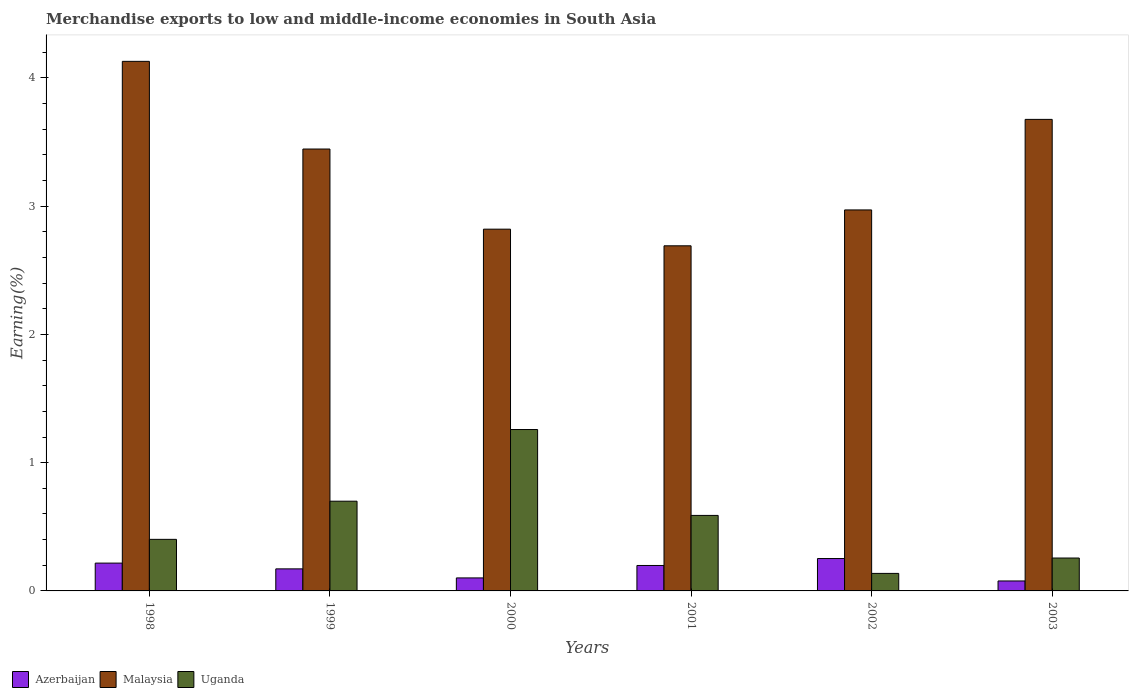How many different coloured bars are there?
Provide a succinct answer. 3. How many bars are there on the 4th tick from the right?
Ensure brevity in your answer.  3. In how many cases, is the number of bars for a given year not equal to the number of legend labels?
Provide a short and direct response. 0. What is the percentage of amount earned from merchandise exports in Uganda in 1998?
Ensure brevity in your answer.  0.4. Across all years, what is the maximum percentage of amount earned from merchandise exports in Azerbaijan?
Your response must be concise. 0.25. Across all years, what is the minimum percentage of amount earned from merchandise exports in Malaysia?
Keep it short and to the point. 2.69. What is the total percentage of amount earned from merchandise exports in Uganda in the graph?
Keep it short and to the point. 3.34. What is the difference between the percentage of amount earned from merchandise exports in Uganda in 1998 and that in 1999?
Provide a succinct answer. -0.3. What is the difference between the percentage of amount earned from merchandise exports in Uganda in 2003 and the percentage of amount earned from merchandise exports in Malaysia in 1999?
Your answer should be compact. -3.19. What is the average percentage of amount earned from merchandise exports in Azerbaijan per year?
Ensure brevity in your answer.  0.17. In the year 1999, what is the difference between the percentage of amount earned from merchandise exports in Azerbaijan and percentage of amount earned from merchandise exports in Uganda?
Offer a terse response. -0.53. In how many years, is the percentage of amount earned from merchandise exports in Malaysia greater than 0.6000000000000001 %?
Ensure brevity in your answer.  6. What is the ratio of the percentage of amount earned from merchandise exports in Azerbaijan in 1998 to that in 2002?
Provide a succinct answer. 0.86. What is the difference between the highest and the second highest percentage of amount earned from merchandise exports in Azerbaijan?
Offer a terse response. 0.04. What is the difference between the highest and the lowest percentage of amount earned from merchandise exports in Malaysia?
Offer a very short reply. 1.44. In how many years, is the percentage of amount earned from merchandise exports in Azerbaijan greater than the average percentage of amount earned from merchandise exports in Azerbaijan taken over all years?
Your answer should be compact. 4. Is the sum of the percentage of amount earned from merchandise exports in Malaysia in 2000 and 2001 greater than the maximum percentage of amount earned from merchandise exports in Azerbaijan across all years?
Offer a terse response. Yes. What does the 2nd bar from the left in 2001 represents?
Keep it short and to the point. Malaysia. What does the 3rd bar from the right in 2000 represents?
Keep it short and to the point. Azerbaijan. Is it the case that in every year, the sum of the percentage of amount earned from merchandise exports in Azerbaijan and percentage of amount earned from merchandise exports in Uganda is greater than the percentage of amount earned from merchandise exports in Malaysia?
Your answer should be very brief. No. How many bars are there?
Make the answer very short. 18. How many years are there in the graph?
Give a very brief answer. 6. Are the values on the major ticks of Y-axis written in scientific E-notation?
Provide a succinct answer. No. Does the graph contain any zero values?
Make the answer very short. No. How many legend labels are there?
Offer a terse response. 3. What is the title of the graph?
Provide a short and direct response. Merchandise exports to low and middle-income economies in South Asia. Does "Sweden" appear as one of the legend labels in the graph?
Provide a succinct answer. No. What is the label or title of the Y-axis?
Offer a terse response. Earning(%). What is the Earning(%) in Azerbaijan in 1998?
Keep it short and to the point. 0.22. What is the Earning(%) of Malaysia in 1998?
Your response must be concise. 4.13. What is the Earning(%) in Uganda in 1998?
Your answer should be very brief. 0.4. What is the Earning(%) in Azerbaijan in 1999?
Your answer should be compact. 0.17. What is the Earning(%) of Malaysia in 1999?
Provide a succinct answer. 3.45. What is the Earning(%) of Uganda in 1999?
Offer a terse response. 0.7. What is the Earning(%) in Azerbaijan in 2000?
Your response must be concise. 0.1. What is the Earning(%) of Malaysia in 2000?
Your response must be concise. 2.82. What is the Earning(%) of Uganda in 2000?
Make the answer very short. 1.26. What is the Earning(%) in Azerbaijan in 2001?
Offer a very short reply. 0.2. What is the Earning(%) of Malaysia in 2001?
Provide a succinct answer. 2.69. What is the Earning(%) in Uganda in 2001?
Offer a very short reply. 0.59. What is the Earning(%) in Azerbaijan in 2002?
Keep it short and to the point. 0.25. What is the Earning(%) in Malaysia in 2002?
Ensure brevity in your answer.  2.97. What is the Earning(%) in Uganda in 2002?
Give a very brief answer. 0.14. What is the Earning(%) in Azerbaijan in 2003?
Offer a terse response. 0.08. What is the Earning(%) of Malaysia in 2003?
Keep it short and to the point. 3.68. What is the Earning(%) of Uganda in 2003?
Provide a succinct answer. 0.26. Across all years, what is the maximum Earning(%) in Azerbaijan?
Ensure brevity in your answer.  0.25. Across all years, what is the maximum Earning(%) in Malaysia?
Provide a short and direct response. 4.13. Across all years, what is the maximum Earning(%) of Uganda?
Make the answer very short. 1.26. Across all years, what is the minimum Earning(%) in Azerbaijan?
Provide a short and direct response. 0.08. Across all years, what is the minimum Earning(%) of Malaysia?
Give a very brief answer. 2.69. Across all years, what is the minimum Earning(%) of Uganda?
Your answer should be compact. 0.14. What is the total Earning(%) of Azerbaijan in the graph?
Ensure brevity in your answer.  1.02. What is the total Earning(%) of Malaysia in the graph?
Keep it short and to the point. 19.73. What is the total Earning(%) in Uganda in the graph?
Your response must be concise. 3.34. What is the difference between the Earning(%) of Azerbaijan in 1998 and that in 1999?
Ensure brevity in your answer.  0.04. What is the difference between the Earning(%) of Malaysia in 1998 and that in 1999?
Your response must be concise. 0.68. What is the difference between the Earning(%) in Uganda in 1998 and that in 1999?
Give a very brief answer. -0.3. What is the difference between the Earning(%) of Azerbaijan in 1998 and that in 2000?
Offer a very short reply. 0.12. What is the difference between the Earning(%) of Malaysia in 1998 and that in 2000?
Your answer should be compact. 1.31. What is the difference between the Earning(%) in Uganda in 1998 and that in 2000?
Keep it short and to the point. -0.86. What is the difference between the Earning(%) in Azerbaijan in 1998 and that in 2001?
Provide a short and direct response. 0.02. What is the difference between the Earning(%) in Malaysia in 1998 and that in 2001?
Keep it short and to the point. 1.44. What is the difference between the Earning(%) of Uganda in 1998 and that in 2001?
Offer a terse response. -0.19. What is the difference between the Earning(%) of Azerbaijan in 1998 and that in 2002?
Ensure brevity in your answer.  -0.04. What is the difference between the Earning(%) of Malaysia in 1998 and that in 2002?
Provide a succinct answer. 1.16. What is the difference between the Earning(%) in Uganda in 1998 and that in 2002?
Provide a short and direct response. 0.27. What is the difference between the Earning(%) in Azerbaijan in 1998 and that in 2003?
Ensure brevity in your answer.  0.14. What is the difference between the Earning(%) of Malaysia in 1998 and that in 2003?
Provide a short and direct response. 0.45. What is the difference between the Earning(%) in Uganda in 1998 and that in 2003?
Offer a terse response. 0.15. What is the difference between the Earning(%) in Azerbaijan in 1999 and that in 2000?
Your answer should be very brief. 0.07. What is the difference between the Earning(%) of Malaysia in 1999 and that in 2000?
Your answer should be compact. 0.62. What is the difference between the Earning(%) in Uganda in 1999 and that in 2000?
Provide a short and direct response. -0.56. What is the difference between the Earning(%) of Azerbaijan in 1999 and that in 2001?
Your answer should be compact. -0.03. What is the difference between the Earning(%) of Malaysia in 1999 and that in 2001?
Keep it short and to the point. 0.75. What is the difference between the Earning(%) in Uganda in 1999 and that in 2001?
Your answer should be compact. 0.11. What is the difference between the Earning(%) in Azerbaijan in 1999 and that in 2002?
Offer a terse response. -0.08. What is the difference between the Earning(%) in Malaysia in 1999 and that in 2002?
Provide a succinct answer. 0.47. What is the difference between the Earning(%) of Uganda in 1999 and that in 2002?
Make the answer very short. 0.56. What is the difference between the Earning(%) of Azerbaijan in 1999 and that in 2003?
Your answer should be very brief. 0.09. What is the difference between the Earning(%) of Malaysia in 1999 and that in 2003?
Keep it short and to the point. -0.23. What is the difference between the Earning(%) in Uganda in 1999 and that in 2003?
Keep it short and to the point. 0.44. What is the difference between the Earning(%) in Azerbaijan in 2000 and that in 2001?
Your response must be concise. -0.1. What is the difference between the Earning(%) of Malaysia in 2000 and that in 2001?
Your answer should be very brief. 0.13. What is the difference between the Earning(%) of Uganda in 2000 and that in 2001?
Provide a short and direct response. 0.67. What is the difference between the Earning(%) of Azerbaijan in 2000 and that in 2002?
Ensure brevity in your answer.  -0.15. What is the difference between the Earning(%) in Malaysia in 2000 and that in 2002?
Offer a very short reply. -0.15. What is the difference between the Earning(%) in Uganda in 2000 and that in 2002?
Give a very brief answer. 1.12. What is the difference between the Earning(%) in Azerbaijan in 2000 and that in 2003?
Offer a very short reply. 0.02. What is the difference between the Earning(%) in Malaysia in 2000 and that in 2003?
Provide a short and direct response. -0.86. What is the difference between the Earning(%) of Uganda in 2000 and that in 2003?
Offer a terse response. 1. What is the difference between the Earning(%) in Azerbaijan in 2001 and that in 2002?
Your answer should be compact. -0.05. What is the difference between the Earning(%) in Malaysia in 2001 and that in 2002?
Ensure brevity in your answer.  -0.28. What is the difference between the Earning(%) in Uganda in 2001 and that in 2002?
Your response must be concise. 0.45. What is the difference between the Earning(%) in Azerbaijan in 2001 and that in 2003?
Keep it short and to the point. 0.12. What is the difference between the Earning(%) of Malaysia in 2001 and that in 2003?
Your response must be concise. -0.99. What is the difference between the Earning(%) of Uganda in 2001 and that in 2003?
Provide a short and direct response. 0.33. What is the difference between the Earning(%) of Azerbaijan in 2002 and that in 2003?
Keep it short and to the point. 0.17. What is the difference between the Earning(%) in Malaysia in 2002 and that in 2003?
Make the answer very short. -0.71. What is the difference between the Earning(%) in Uganda in 2002 and that in 2003?
Keep it short and to the point. -0.12. What is the difference between the Earning(%) of Azerbaijan in 1998 and the Earning(%) of Malaysia in 1999?
Offer a terse response. -3.23. What is the difference between the Earning(%) in Azerbaijan in 1998 and the Earning(%) in Uganda in 1999?
Your response must be concise. -0.48. What is the difference between the Earning(%) of Malaysia in 1998 and the Earning(%) of Uganda in 1999?
Provide a succinct answer. 3.43. What is the difference between the Earning(%) of Azerbaijan in 1998 and the Earning(%) of Malaysia in 2000?
Give a very brief answer. -2.6. What is the difference between the Earning(%) in Azerbaijan in 1998 and the Earning(%) in Uganda in 2000?
Your answer should be compact. -1.04. What is the difference between the Earning(%) of Malaysia in 1998 and the Earning(%) of Uganda in 2000?
Give a very brief answer. 2.87. What is the difference between the Earning(%) in Azerbaijan in 1998 and the Earning(%) in Malaysia in 2001?
Offer a terse response. -2.47. What is the difference between the Earning(%) of Azerbaijan in 1998 and the Earning(%) of Uganda in 2001?
Offer a terse response. -0.37. What is the difference between the Earning(%) of Malaysia in 1998 and the Earning(%) of Uganda in 2001?
Provide a short and direct response. 3.54. What is the difference between the Earning(%) in Azerbaijan in 1998 and the Earning(%) in Malaysia in 2002?
Offer a very short reply. -2.75. What is the difference between the Earning(%) in Azerbaijan in 1998 and the Earning(%) in Uganda in 2002?
Ensure brevity in your answer.  0.08. What is the difference between the Earning(%) in Malaysia in 1998 and the Earning(%) in Uganda in 2002?
Keep it short and to the point. 3.99. What is the difference between the Earning(%) in Azerbaijan in 1998 and the Earning(%) in Malaysia in 2003?
Keep it short and to the point. -3.46. What is the difference between the Earning(%) in Azerbaijan in 1998 and the Earning(%) in Uganda in 2003?
Offer a terse response. -0.04. What is the difference between the Earning(%) in Malaysia in 1998 and the Earning(%) in Uganda in 2003?
Provide a short and direct response. 3.87. What is the difference between the Earning(%) of Azerbaijan in 1999 and the Earning(%) of Malaysia in 2000?
Provide a short and direct response. -2.65. What is the difference between the Earning(%) of Azerbaijan in 1999 and the Earning(%) of Uganda in 2000?
Provide a succinct answer. -1.09. What is the difference between the Earning(%) in Malaysia in 1999 and the Earning(%) in Uganda in 2000?
Your answer should be compact. 2.19. What is the difference between the Earning(%) of Azerbaijan in 1999 and the Earning(%) of Malaysia in 2001?
Offer a terse response. -2.52. What is the difference between the Earning(%) in Azerbaijan in 1999 and the Earning(%) in Uganda in 2001?
Ensure brevity in your answer.  -0.42. What is the difference between the Earning(%) of Malaysia in 1999 and the Earning(%) of Uganda in 2001?
Offer a very short reply. 2.86. What is the difference between the Earning(%) in Azerbaijan in 1999 and the Earning(%) in Malaysia in 2002?
Provide a short and direct response. -2.8. What is the difference between the Earning(%) of Azerbaijan in 1999 and the Earning(%) of Uganda in 2002?
Make the answer very short. 0.04. What is the difference between the Earning(%) in Malaysia in 1999 and the Earning(%) in Uganda in 2002?
Ensure brevity in your answer.  3.31. What is the difference between the Earning(%) of Azerbaijan in 1999 and the Earning(%) of Malaysia in 2003?
Keep it short and to the point. -3.5. What is the difference between the Earning(%) in Azerbaijan in 1999 and the Earning(%) in Uganda in 2003?
Your response must be concise. -0.08. What is the difference between the Earning(%) in Malaysia in 1999 and the Earning(%) in Uganda in 2003?
Your answer should be very brief. 3.19. What is the difference between the Earning(%) in Azerbaijan in 2000 and the Earning(%) in Malaysia in 2001?
Your answer should be very brief. -2.59. What is the difference between the Earning(%) of Azerbaijan in 2000 and the Earning(%) of Uganda in 2001?
Your answer should be compact. -0.49. What is the difference between the Earning(%) of Malaysia in 2000 and the Earning(%) of Uganda in 2001?
Offer a terse response. 2.23. What is the difference between the Earning(%) in Azerbaijan in 2000 and the Earning(%) in Malaysia in 2002?
Your response must be concise. -2.87. What is the difference between the Earning(%) of Azerbaijan in 2000 and the Earning(%) of Uganda in 2002?
Your answer should be compact. -0.04. What is the difference between the Earning(%) in Malaysia in 2000 and the Earning(%) in Uganda in 2002?
Offer a very short reply. 2.68. What is the difference between the Earning(%) of Azerbaijan in 2000 and the Earning(%) of Malaysia in 2003?
Offer a very short reply. -3.58. What is the difference between the Earning(%) in Azerbaijan in 2000 and the Earning(%) in Uganda in 2003?
Your response must be concise. -0.16. What is the difference between the Earning(%) of Malaysia in 2000 and the Earning(%) of Uganda in 2003?
Provide a short and direct response. 2.56. What is the difference between the Earning(%) in Azerbaijan in 2001 and the Earning(%) in Malaysia in 2002?
Provide a succinct answer. -2.77. What is the difference between the Earning(%) of Azerbaijan in 2001 and the Earning(%) of Uganda in 2002?
Make the answer very short. 0.06. What is the difference between the Earning(%) in Malaysia in 2001 and the Earning(%) in Uganda in 2002?
Your answer should be compact. 2.55. What is the difference between the Earning(%) in Azerbaijan in 2001 and the Earning(%) in Malaysia in 2003?
Offer a terse response. -3.48. What is the difference between the Earning(%) in Azerbaijan in 2001 and the Earning(%) in Uganda in 2003?
Provide a succinct answer. -0.06. What is the difference between the Earning(%) in Malaysia in 2001 and the Earning(%) in Uganda in 2003?
Keep it short and to the point. 2.43. What is the difference between the Earning(%) in Azerbaijan in 2002 and the Earning(%) in Malaysia in 2003?
Provide a short and direct response. -3.42. What is the difference between the Earning(%) in Azerbaijan in 2002 and the Earning(%) in Uganda in 2003?
Your response must be concise. -0. What is the difference between the Earning(%) of Malaysia in 2002 and the Earning(%) of Uganda in 2003?
Your response must be concise. 2.71. What is the average Earning(%) of Azerbaijan per year?
Your answer should be very brief. 0.17. What is the average Earning(%) in Malaysia per year?
Give a very brief answer. 3.29. What is the average Earning(%) in Uganda per year?
Your response must be concise. 0.56. In the year 1998, what is the difference between the Earning(%) of Azerbaijan and Earning(%) of Malaysia?
Give a very brief answer. -3.91. In the year 1998, what is the difference between the Earning(%) of Azerbaijan and Earning(%) of Uganda?
Provide a short and direct response. -0.19. In the year 1998, what is the difference between the Earning(%) in Malaysia and Earning(%) in Uganda?
Ensure brevity in your answer.  3.73. In the year 1999, what is the difference between the Earning(%) of Azerbaijan and Earning(%) of Malaysia?
Your answer should be compact. -3.27. In the year 1999, what is the difference between the Earning(%) in Azerbaijan and Earning(%) in Uganda?
Offer a terse response. -0.53. In the year 1999, what is the difference between the Earning(%) in Malaysia and Earning(%) in Uganda?
Provide a succinct answer. 2.75. In the year 2000, what is the difference between the Earning(%) of Azerbaijan and Earning(%) of Malaysia?
Your response must be concise. -2.72. In the year 2000, what is the difference between the Earning(%) in Azerbaijan and Earning(%) in Uganda?
Offer a terse response. -1.16. In the year 2000, what is the difference between the Earning(%) of Malaysia and Earning(%) of Uganda?
Your answer should be compact. 1.56. In the year 2001, what is the difference between the Earning(%) in Azerbaijan and Earning(%) in Malaysia?
Keep it short and to the point. -2.49. In the year 2001, what is the difference between the Earning(%) of Azerbaijan and Earning(%) of Uganda?
Your answer should be compact. -0.39. In the year 2001, what is the difference between the Earning(%) in Malaysia and Earning(%) in Uganda?
Your answer should be compact. 2.1. In the year 2002, what is the difference between the Earning(%) in Azerbaijan and Earning(%) in Malaysia?
Provide a short and direct response. -2.72. In the year 2002, what is the difference between the Earning(%) of Azerbaijan and Earning(%) of Uganda?
Your response must be concise. 0.12. In the year 2002, what is the difference between the Earning(%) in Malaysia and Earning(%) in Uganda?
Offer a very short reply. 2.83. In the year 2003, what is the difference between the Earning(%) in Azerbaijan and Earning(%) in Malaysia?
Give a very brief answer. -3.6. In the year 2003, what is the difference between the Earning(%) of Azerbaijan and Earning(%) of Uganda?
Your answer should be very brief. -0.18. In the year 2003, what is the difference between the Earning(%) in Malaysia and Earning(%) in Uganda?
Keep it short and to the point. 3.42. What is the ratio of the Earning(%) of Azerbaijan in 1998 to that in 1999?
Provide a short and direct response. 1.26. What is the ratio of the Earning(%) in Malaysia in 1998 to that in 1999?
Keep it short and to the point. 1.2. What is the ratio of the Earning(%) of Uganda in 1998 to that in 1999?
Make the answer very short. 0.57. What is the ratio of the Earning(%) of Azerbaijan in 1998 to that in 2000?
Your answer should be very brief. 2.14. What is the ratio of the Earning(%) of Malaysia in 1998 to that in 2000?
Ensure brevity in your answer.  1.46. What is the ratio of the Earning(%) of Uganda in 1998 to that in 2000?
Make the answer very short. 0.32. What is the ratio of the Earning(%) in Azerbaijan in 1998 to that in 2001?
Offer a very short reply. 1.09. What is the ratio of the Earning(%) of Malaysia in 1998 to that in 2001?
Keep it short and to the point. 1.53. What is the ratio of the Earning(%) in Uganda in 1998 to that in 2001?
Provide a short and direct response. 0.68. What is the ratio of the Earning(%) of Azerbaijan in 1998 to that in 2002?
Your answer should be very brief. 0.86. What is the ratio of the Earning(%) of Malaysia in 1998 to that in 2002?
Make the answer very short. 1.39. What is the ratio of the Earning(%) in Uganda in 1998 to that in 2002?
Provide a succinct answer. 2.94. What is the ratio of the Earning(%) in Azerbaijan in 1998 to that in 2003?
Offer a very short reply. 2.79. What is the ratio of the Earning(%) in Malaysia in 1998 to that in 2003?
Offer a terse response. 1.12. What is the ratio of the Earning(%) in Uganda in 1998 to that in 2003?
Offer a very short reply. 1.57. What is the ratio of the Earning(%) in Azerbaijan in 1999 to that in 2000?
Offer a terse response. 1.7. What is the ratio of the Earning(%) of Malaysia in 1999 to that in 2000?
Your answer should be compact. 1.22. What is the ratio of the Earning(%) of Uganda in 1999 to that in 2000?
Your answer should be very brief. 0.56. What is the ratio of the Earning(%) of Azerbaijan in 1999 to that in 2001?
Ensure brevity in your answer.  0.87. What is the ratio of the Earning(%) in Malaysia in 1999 to that in 2001?
Your response must be concise. 1.28. What is the ratio of the Earning(%) of Uganda in 1999 to that in 2001?
Ensure brevity in your answer.  1.19. What is the ratio of the Earning(%) of Azerbaijan in 1999 to that in 2002?
Your response must be concise. 0.68. What is the ratio of the Earning(%) of Malaysia in 1999 to that in 2002?
Make the answer very short. 1.16. What is the ratio of the Earning(%) in Uganda in 1999 to that in 2002?
Provide a succinct answer. 5.12. What is the ratio of the Earning(%) in Azerbaijan in 1999 to that in 2003?
Your response must be concise. 2.21. What is the ratio of the Earning(%) in Malaysia in 1999 to that in 2003?
Keep it short and to the point. 0.94. What is the ratio of the Earning(%) in Uganda in 1999 to that in 2003?
Your response must be concise. 2.73. What is the ratio of the Earning(%) of Azerbaijan in 2000 to that in 2001?
Your answer should be compact. 0.51. What is the ratio of the Earning(%) in Malaysia in 2000 to that in 2001?
Keep it short and to the point. 1.05. What is the ratio of the Earning(%) of Uganda in 2000 to that in 2001?
Your answer should be compact. 2.14. What is the ratio of the Earning(%) in Azerbaijan in 2000 to that in 2002?
Keep it short and to the point. 0.4. What is the ratio of the Earning(%) in Malaysia in 2000 to that in 2002?
Offer a terse response. 0.95. What is the ratio of the Earning(%) of Uganda in 2000 to that in 2002?
Your answer should be very brief. 9.21. What is the ratio of the Earning(%) in Azerbaijan in 2000 to that in 2003?
Offer a very short reply. 1.31. What is the ratio of the Earning(%) of Malaysia in 2000 to that in 2003?
Your answer should be very brief. 0.77. What is the ratio of the Earning(%) of Uganda in 2000 to that in 2003?
Provide a succinct answer. 4.91. What is the ratio of the Earning(%) of Azerbaijan in 2001 to that in 2002?
Ensure brevity in your answer.  0.79. What is the ratio of the Earning(%) of Malaysia in 2001 to that in 2002?
Make the answer very short. 0.91. What is the ratio of the Earning(%) of Uganda in 2001 to that in 2002?
Offer a very short reply. 4.31. What is the ratio of the Earning(%) of Azerbaijan in 2001 to that in 2003?
Your answer should be very brief. 2.55. What is the ratio of the Earning(%) in Malaysia in 2001 to that in 2003?
Make the answer very short. 0.73. What is the ratio of the Earning(%) in Uganda in 2001 to that in 2003?
Ensure brevity in your answer.  2.3. What is the ratio of the Earning(%) of Azerbaijan in 2002 to that in 2003?
Provide a short and direct response. 3.25. What is the ratio of the Earning(%) in Malaysia in 2002 to that in 2003?
Your response must be concise. 0.81. What is the ratio of the Earning(%) in Uganda in 2002 to that in 2003?
Offer a terse response. 0.53. What is the difference between the highest and the second highest Earning(%) in Azerbaijan?
Keep it short and to the point. 0.04. What is the difference between the highest and the second highest Earning(%) of Malaysia?
Give a very brief answer. 0.45. What is the difference between the highest and the second highest Earning(%) in Uganda?
Your answer should be compact. 0.56. What is the difference between the highest and the lowest Earning(%) in Azerbaijan?
Provide a short and direct response. 0.17. What is the difference between the highest and the lowest Earning(%) in Malaysia?
Your answer should be very brief. 1.44. What is the difference between the highest and the lowest Earning(%) of Uganda?
Provide a succinct answer. 1.12. 